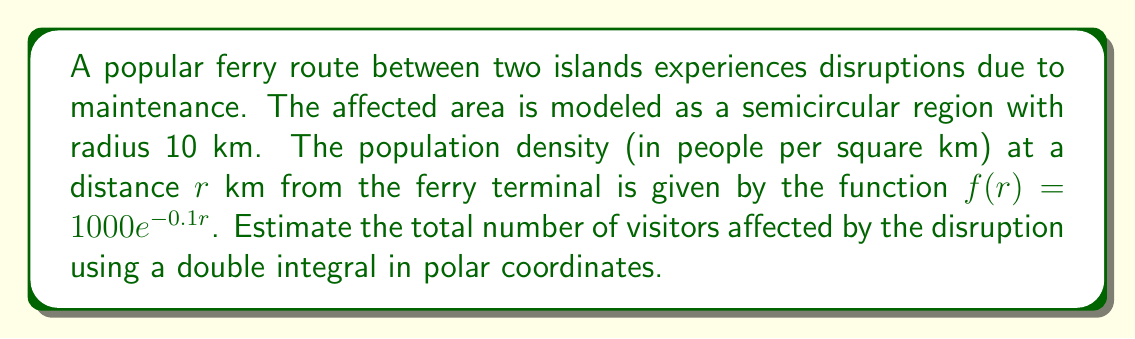Could you help me with this problem? To solve this problem, we'll follow these steps:

1) The area is a semicircle, so we'll use polar coordinates with $r$ ranging from 0 to 10 km, and $\theta$ ranging from 0 to $\pi$ radians.

2) The double integral in polar coordinates for population is:

   $$N = \int_{0}^{\pi} \int_{0}^{10} f(r) \cdot r \, dr \, d\theta$$

3) Substituting the given density function:

   $$N = \int_{0}^{\pi} \int_{0}^{10} 1000e^{-0.1r} \cdot r \, dr \, d\theta$$

4) The $\theta$ integral is simply $\pi$, so we can simplify:

   $$N = \pi \int_{0}^{10} 1000re^{-0.1r} \, dr$$

5) To solve this, we use integration by parts. Let $u = r$ and $dv = 1000e^{-0.1r}dr$. Then $du = dr$ and $v = -10000e^{-0.1r}$.

   $$N = \pi \left[-10000re^{-0.1r}\right]_{0}^{10} + \pi \int_{0}^{10} 10000e^{-0.1r} \, dr$$

6) Evaluating the first part:

   $$N = \pi \left[-100000e^{-1} + 0\right] + \pi \left[-100000e^{-0.1r}\right]_{0}^{10}$$

7) Simplifying:

   $$N = \pi \left[-100000e^{-1} - 100000e^{-1} + 100000\right]$$

8) Calculating the final result:

   $$N \approx 194,845$$

Thus, approximately 194,845 visitors are affected by the ferry disruption.
Answer: 194,845 visitors 